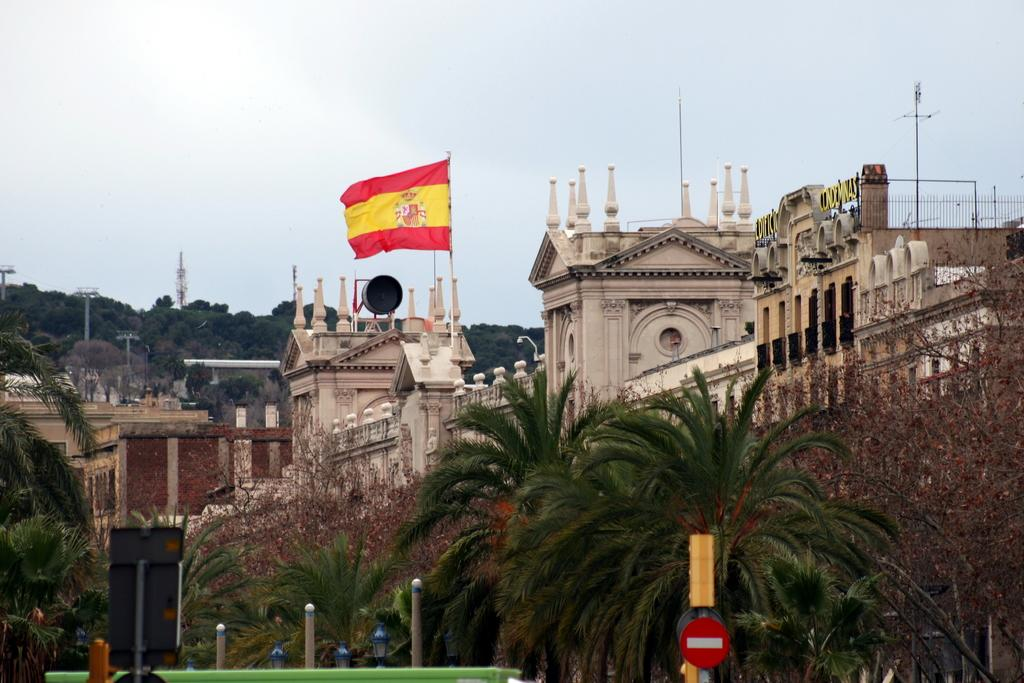What type of structures can be seen in the image? There are buildings in the image. What natural elements are present in the image? There are trees in the image. What type of poles can be seen in the image? Metal poles and electric poles are visible in the image. What is attached to the metal poles? There is a flag attached to the metal poles. What can be seen in the background of the image? The sky is visible in the background of the image. What type of receipt can be seen in the image? There is no receipt present in the image. What is the reaction of the trees to the electric poles in the image? There is no reaction of the trees to the electric poles, as trees do not have the ability to react in the same way as living beings. 